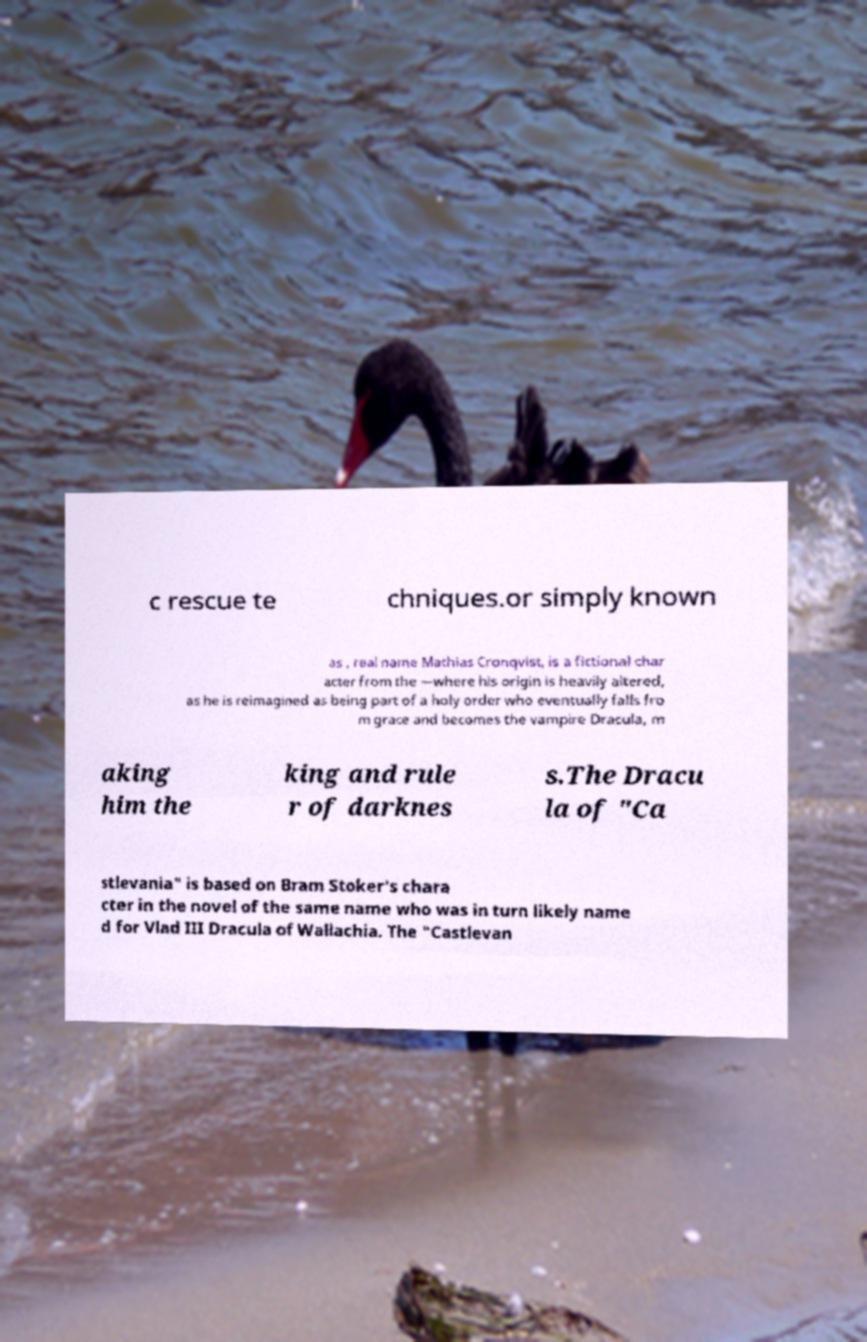There's text embedded in this image that I need extracted. Can you transcribe it verbatim? c rescue te chniques.or simply known as , real name Mathias Cronqvist, is a fictional char acter from the —where his origin is heavily altered, as he is reimagined as being part of a holy order who eventually falls fro m grace and becomes the vampire Dracula, m aking him the king and rule r of darknes s.The Dracu la of "Ca stlevania" is based on Bram Stoker's chara cter in the novel of the same name who was in turn likely name d for Vlad III Dracula of Wallachia. The "Castlevan 